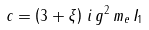Convert formula to latex. <formula><loc_0><loc_0><loc_500><loc_500>c = \left ( 3 + \xi \right ) \, i \, g ^ { 2 } \, m _ { e } \, I _ { 1 }</formula> 